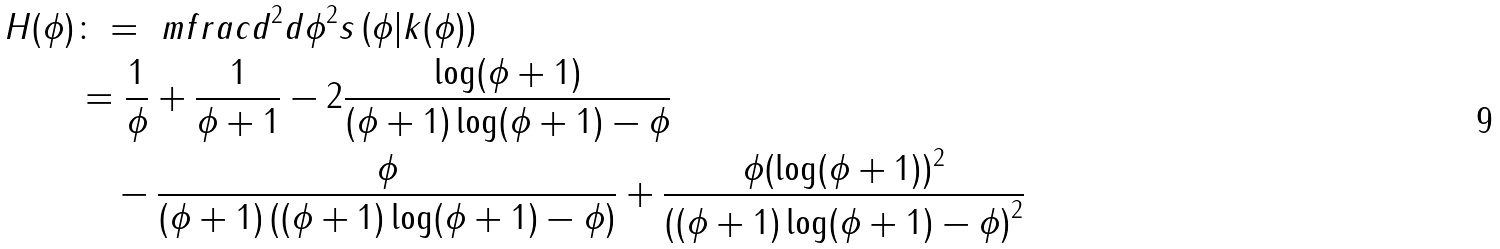<formula> <loc_0><loc_0><loc_500><loc_500>H ( \phi ) & \colon = \ m f r a c { d ^ { 2 } } { d \phi ^ { 2 } } s \left ( \phi | k ( \phi ) \right ) \\ & = \frac { 1 } { \phi } + \frac { 1 } { \phi + 1 } - 2 \frac { \log ( \phi + 1 ) } { ( \phi + 1 ) \log ( \phi + 1 ) - \phi } \\ & \quad - \frac { \phi } { ( \phi + 1 ) \left ( ( \phi + 1 ) \log ( \phi + 1 ) - \phi \right ) } + \frac { \phi ( \log ( \phi + 1 ) ) ^ { 2 } } { \left ( ( \phi + 1 ) \log ( \phi + 1 ) - \phi \right ) ^ { 2 } }</formula> 